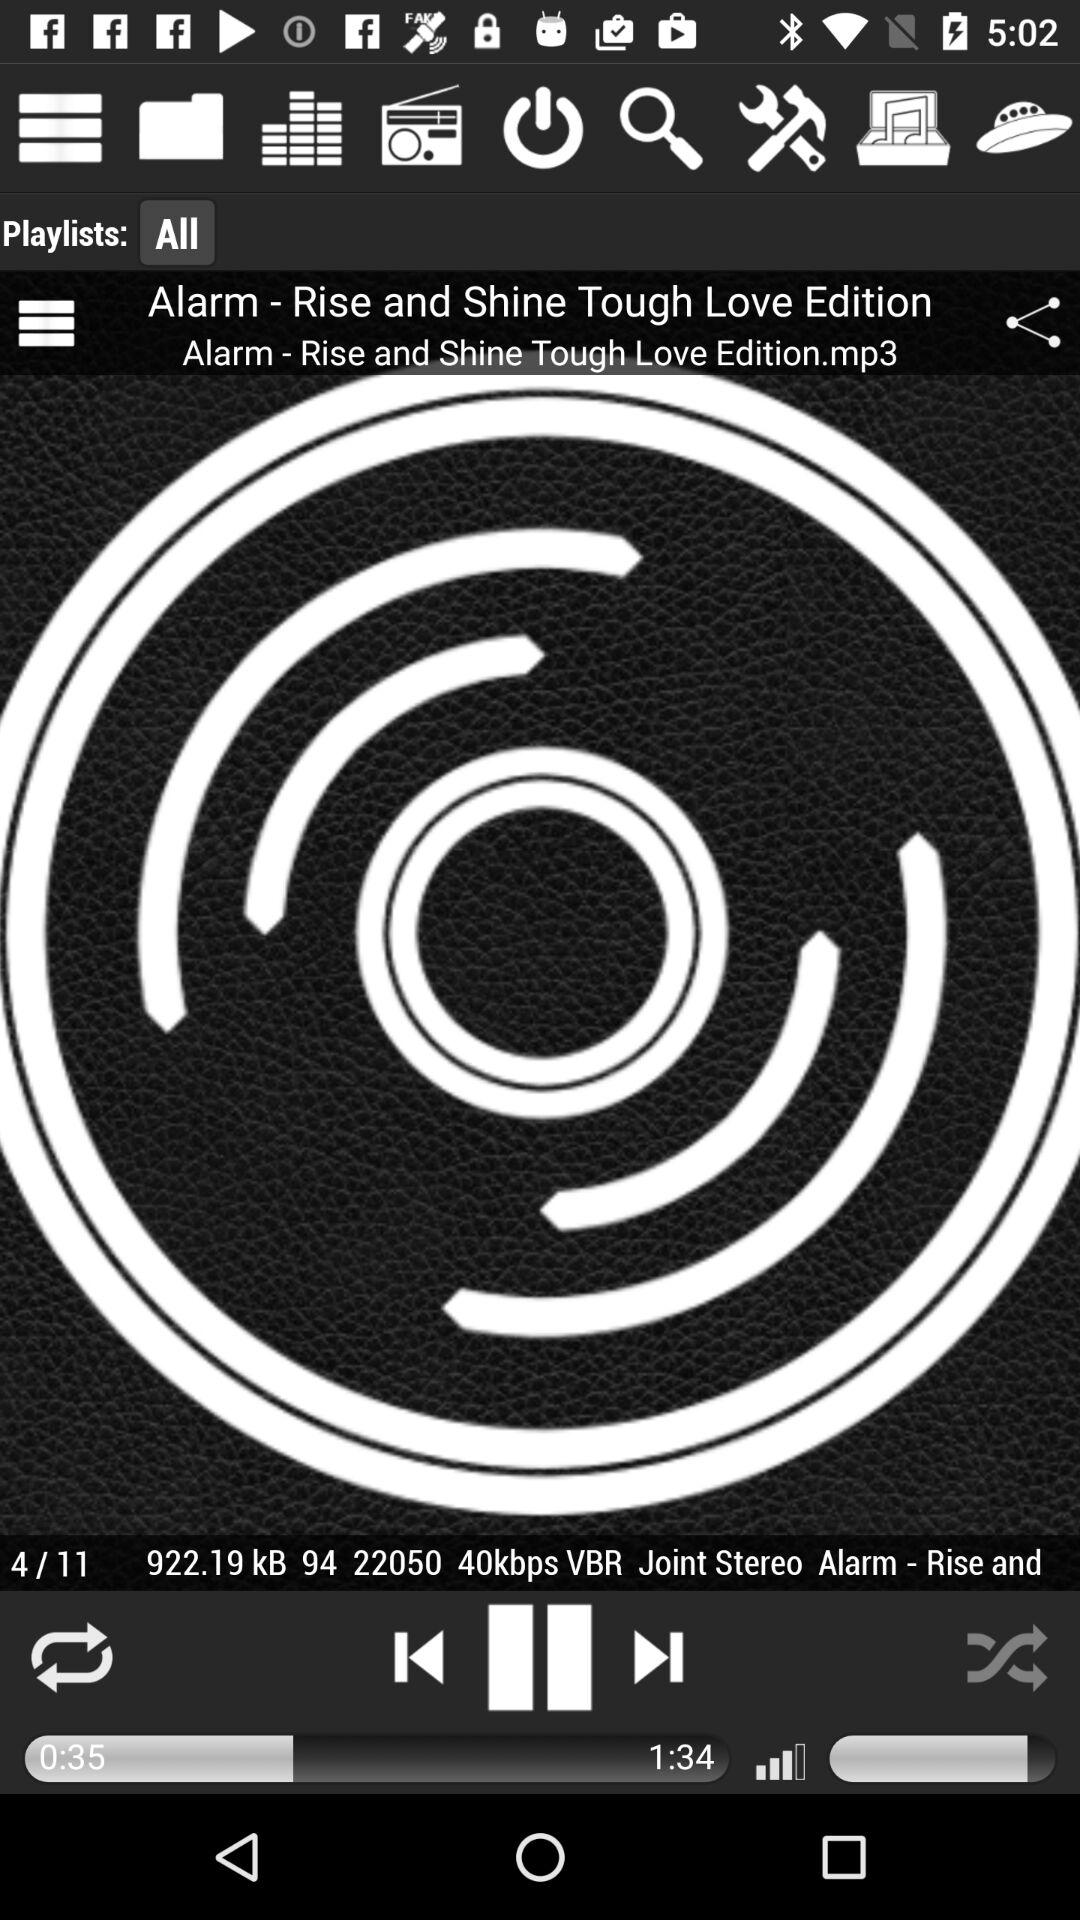What is the total duration of the audio? The total duration of the audio is 1 minute 34 seconds. 